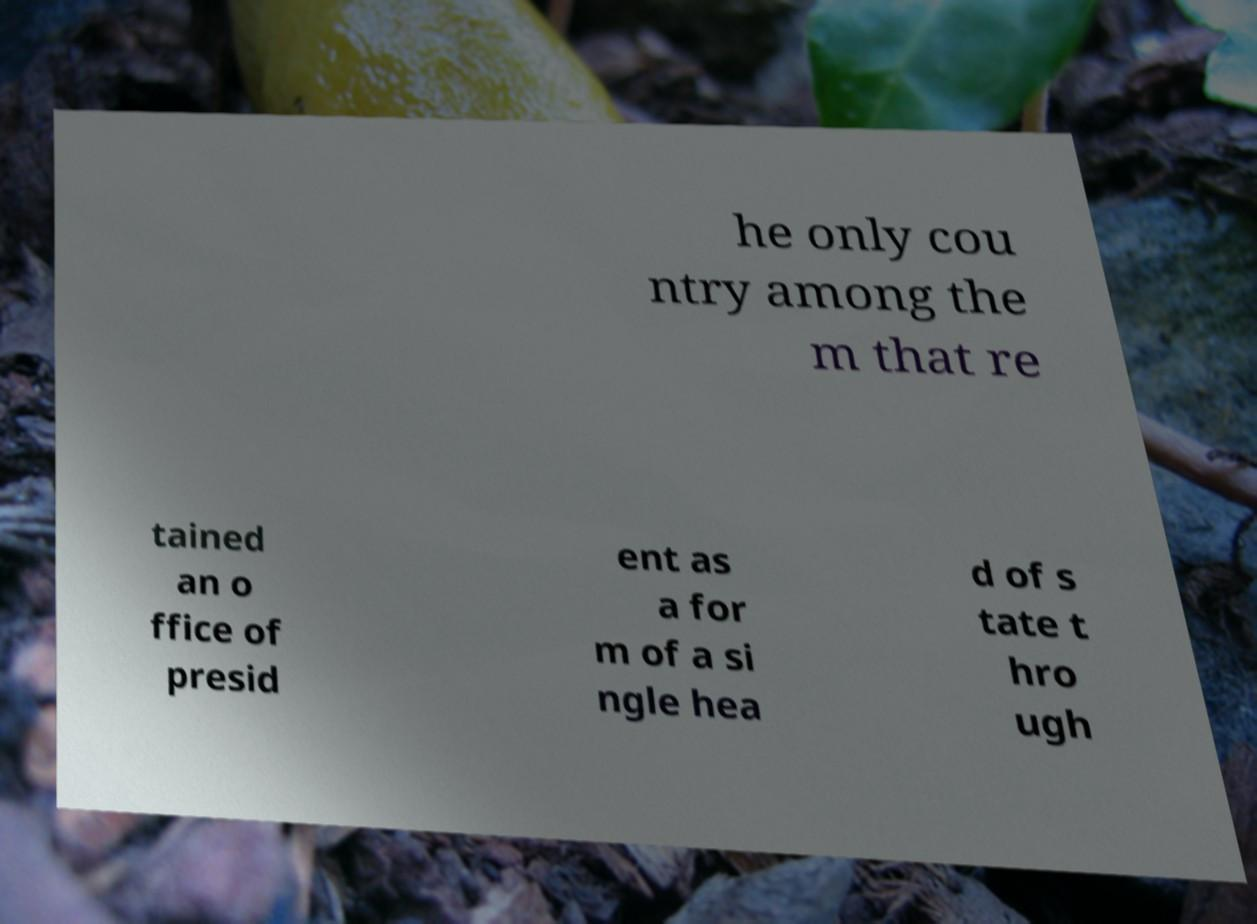Please read and relay the text visible in this image. What does it say? he only cou ntry among the m that re tained an o ffice of presid ent as a for m of a si ngle hea d of s tate t hro ugh 